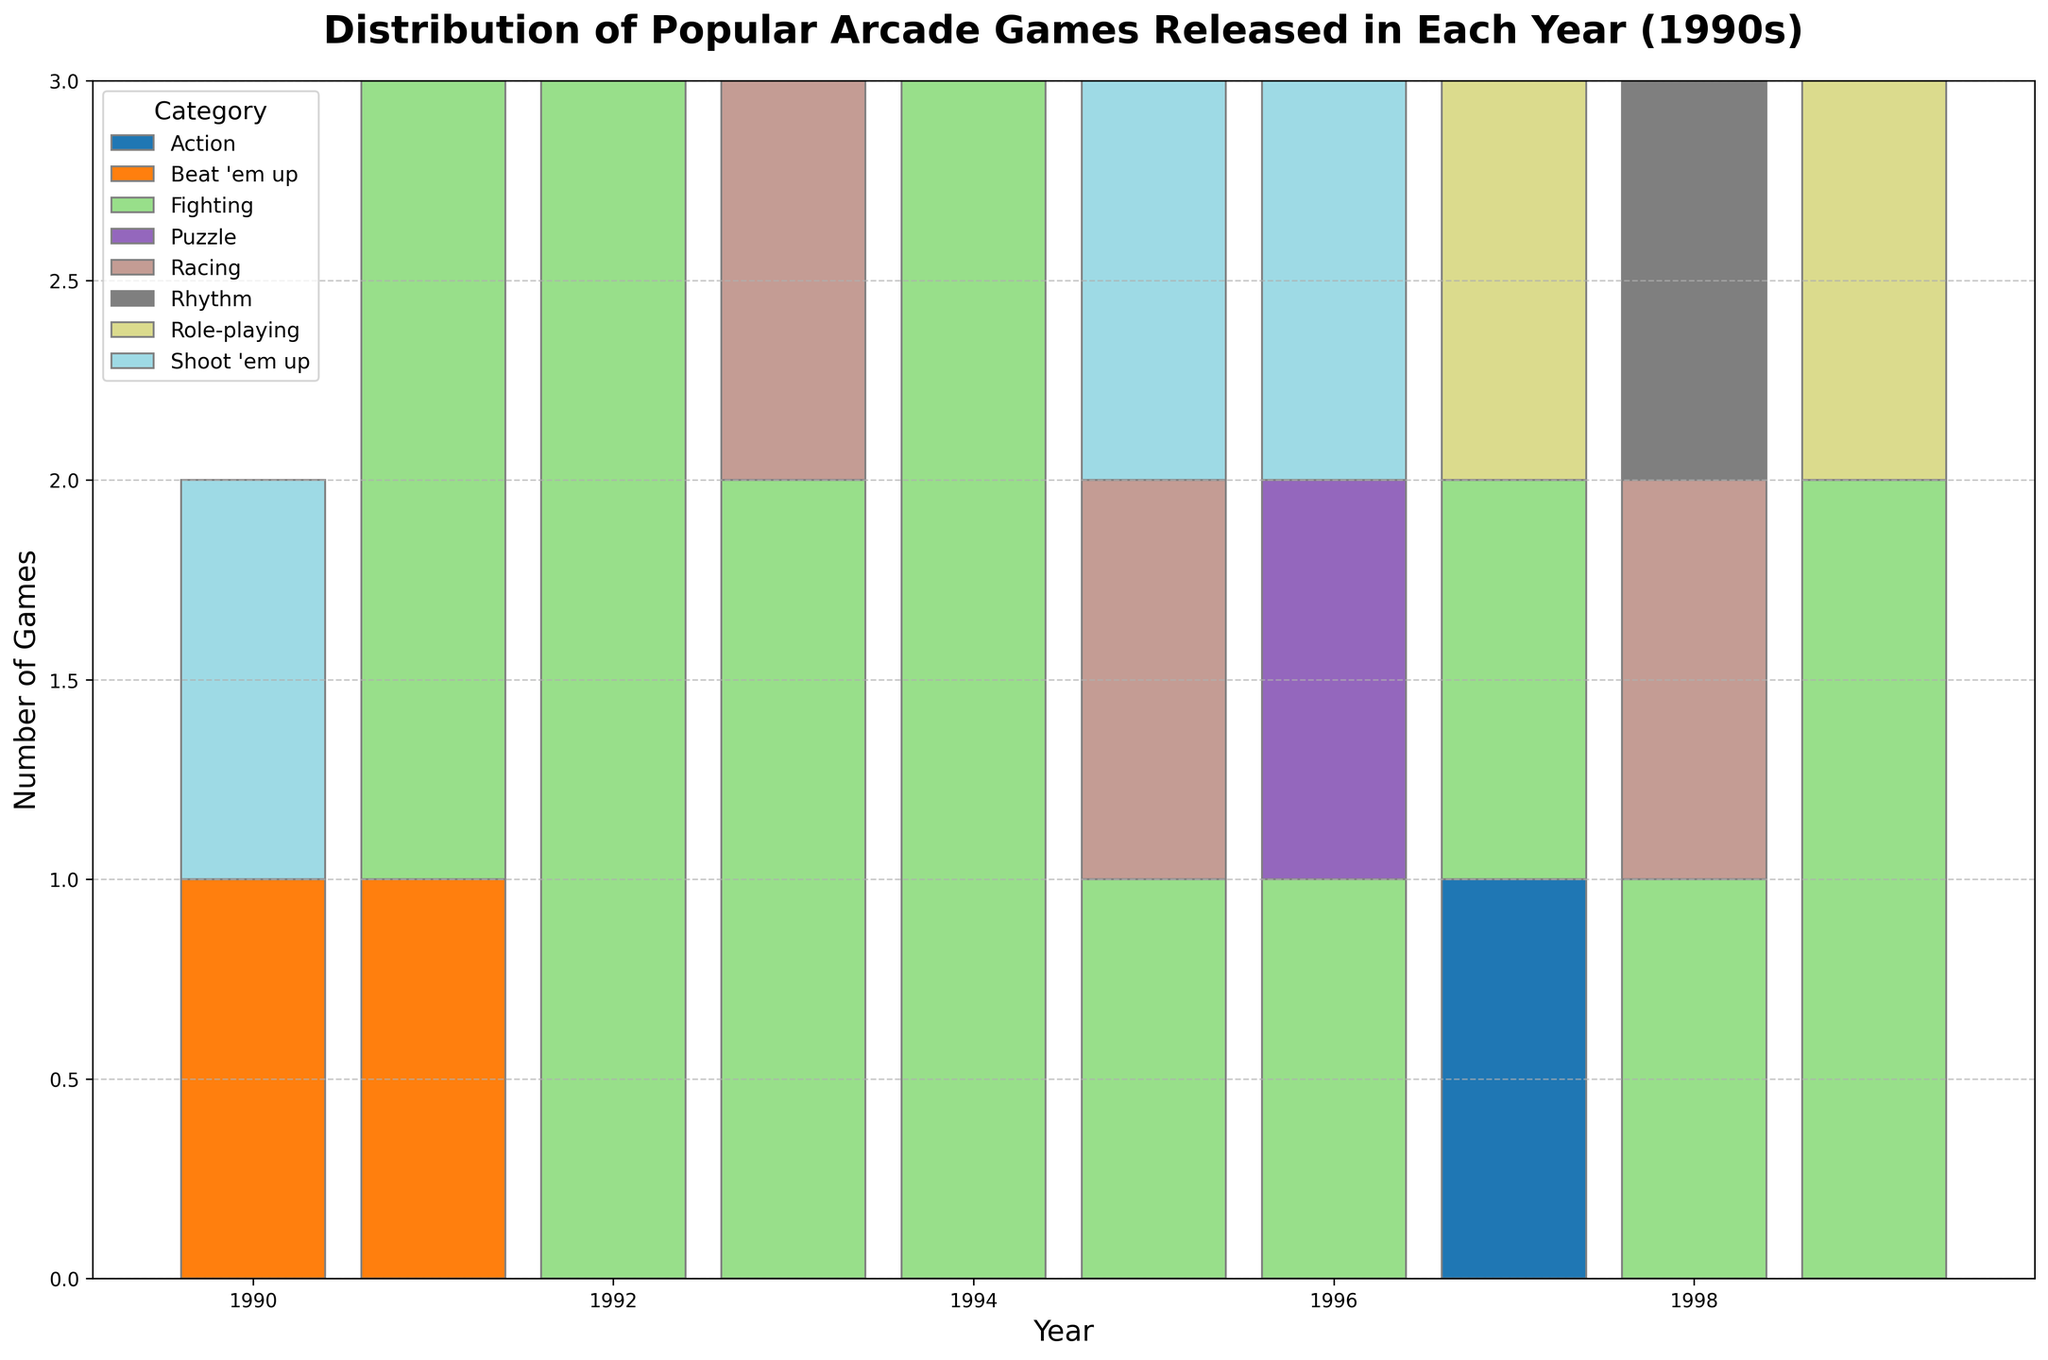Which year had the highest number of Fighting games released? First, identify the bars representing Fighting games in each year. The year with the tallest total bar for the Fighting category is the year with the highest number of Fighting games.
Answer: 1994 How many Racing games were released in the entire decade? Sum the heights of the bars representing Racing games across all years from 1990 to 1999.
Answer: 3 Which category had the least number of releases in 1997? Check the heights of the bars for 1997 and find the shortest one. The category corresponding to the shortest bar is the answer.
Answer: Action Compare the number of Beat 'em up games released in 1990 with 1991. Which year had more? Identify the height of the bars representing Beat 'em up games for 1990 and 1991. Compare these heights to see which one is taller.
Answer: 1991 How many more Fighting games were released in 1994 compared to 1990? Find the height of the Fighting games' bars for 1994 and 1990. Subtract the height of the 1990 bar from the height of the 1994 bar to determine the difference.
Answer: 5 What is the total number of games released in 1995? Add the heights of all category bars for the year 1995 to get the total number of games released that year.
Answer: 3 How does the number of categories represented in 1993 compare to those in 1996? Count the number of distinct bars for each category in the years 1993 and 1996, and compare these counts.
Answer: 1993 has more categories Which year saw the highest total number of Shoot 'em up games? Examine the height of Shoot 'em up bars for each year and identify the year with the tallest bar in that category.
Answer: 1990 What is the ratio of Role-playing games to Action games released in the 1990s? Count the total number of Role-playing and Action games released from 1990 to 1999. Divide the number of Role-playing games by the number of Action games to get the ratio.
Answer: 2:1 Which year had games released in the most number of different categories? Count the number of distinct categories represented by bars for each year and find the year with the highest count.
Answer: 1997 